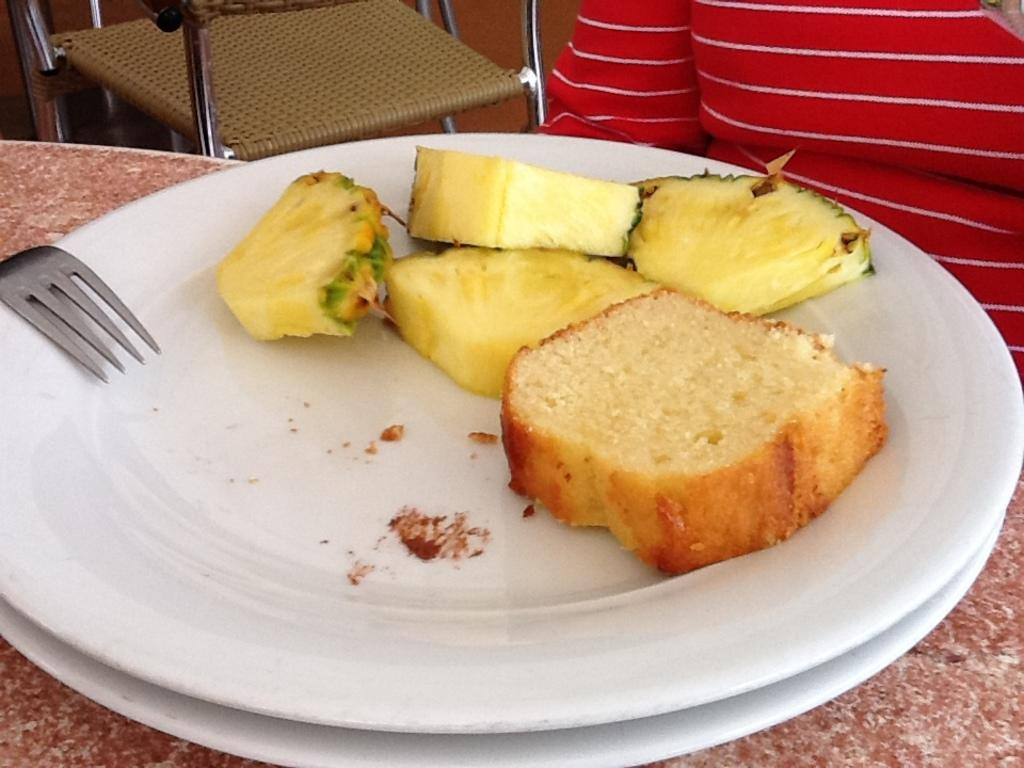How many plates are visible in the image? There are two plates in the image. What is on one of the plates? One plate has food on it. What utensil can be seen in the image? There is a fork in the image. What type of furniture is present in the image? There is a chair in the image. Who or what is in the image? There is a person in the image. How many cats are crying in the image? There are no cats or crying sounds present in the image. 